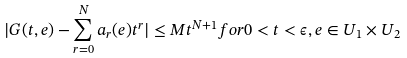Convert formula to latex. <formula><loc_0><loc_0><loc_500><loc_500>| G ( t , e ) - \sum _ { r = 0 } ^ { N } a _ { r } ( e ) t ^ { r } | \leq M t ^ { N + 1 } f o r 0 < t < \epsilon , e \in U _ { 1 } \times U _ { 2 }</formula> 